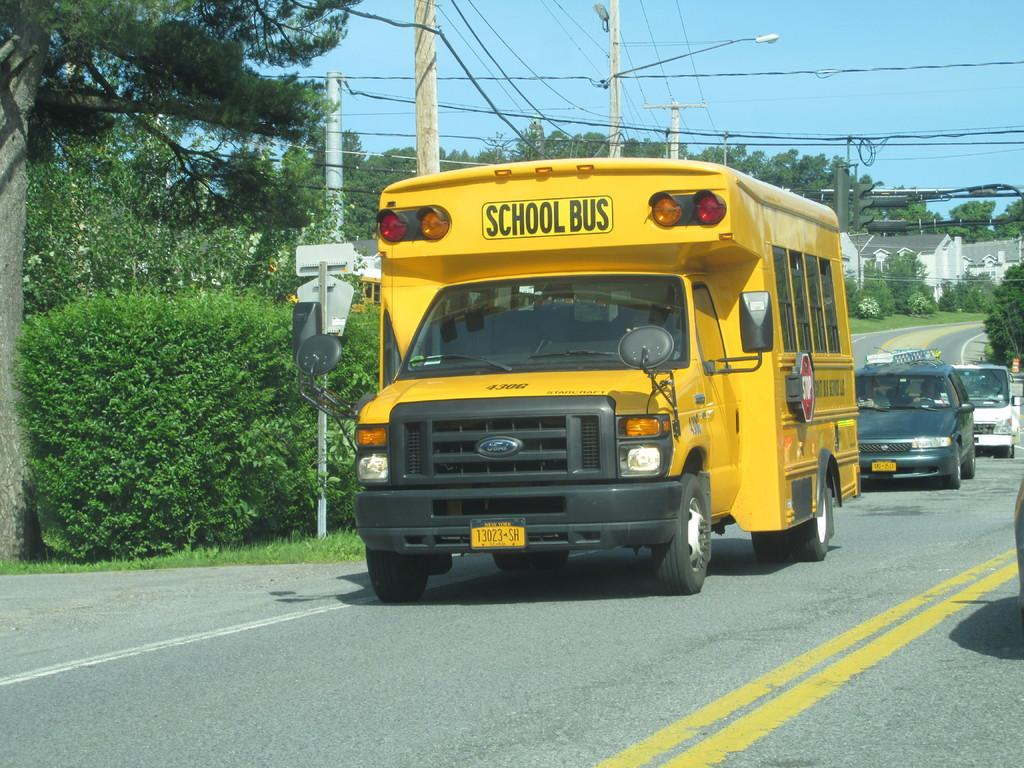What is happening on the road in the image? Vehicles are on the road in the image. What can be seen besides the road in the image? There are sign boards, houses, plants, trees, and current poles in the background. What is the color of the sky in the image? The sky is blue in the image. Can you see any tails on the vehicles in the image? There are no tails visible on the vehicles in the image. What type of fold can be seen in the plants in the image? There are no plants with visible folds in the image; only trees are mentioned. 